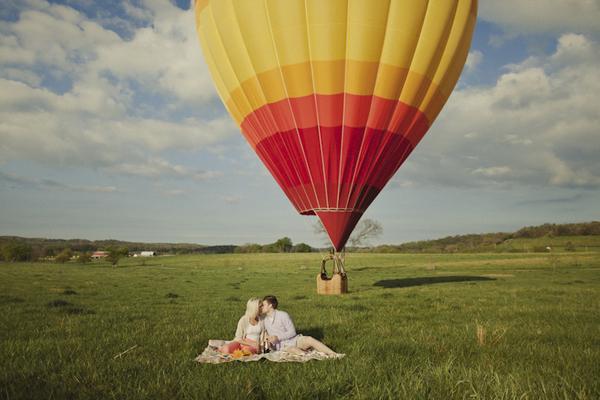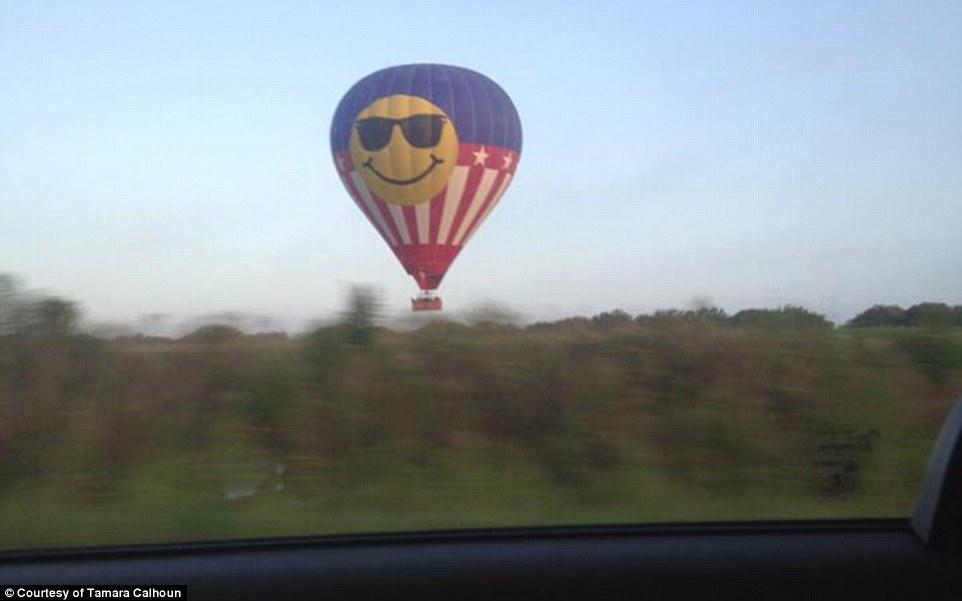The first image is the image on the left, the second image is the image on the right. Analyze the images presented: Is the assertion "An image shows a solid-red balloon floating above a green field." valid? Answer yes or no. No. The first image is the image on the left, the second image is the image on the right. Analyze the images presented: Is the assertion "The balloon is in the air in the image on the left." valid? Answer yes or no. No. 